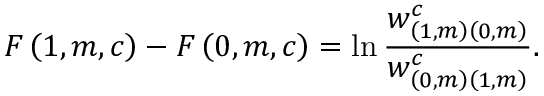Convert formula to latex. <formula><loc_0><loc_0><loc_500><loc_500>F \left ( 1 , m , c \right ) - F \left ( 0 , m , c \right ) = \ln \frac { w _ { \left ( 1 , m \right ) \left ( 0 , m \right ) } ^ { c } } { w _ { \left ( 0 , m \right ) \left ( 1 , m \right ) } ^ { c } } .</formula> 